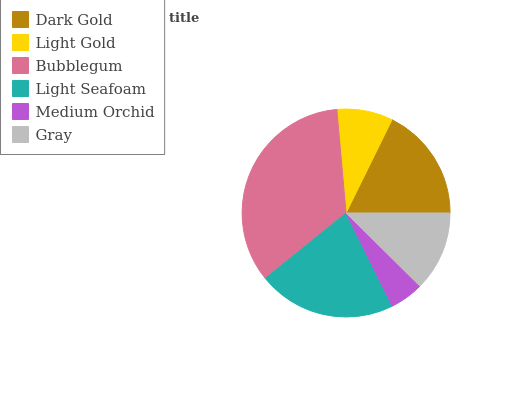Is Medium Orchid the minimum?
Answer yes or no. Yes. Is Bubblegum the maximum?
Answer yes or no. Yes. Is Light Gold the minimum?
Answer yes or no. No. Is Light Gold the maximum?
Answer yes or no. No. Is Dark Gold greater than Light Gold?
Answer yes or no. Yes. Is Light Gold less than Dark Gold?
Answer yes or no. Yes. Is Light Gold greater than Dark Gold?
Answer yes or no. No. Is Dark Gold less than Light Gold?
Answer yes or no. No. Is Dark Gold the high median?
Answer yes or no. Yes. Is Gray the low median?
Answer yes or no. Yes. Is Light Seafoam the high median?
Answer yes or no. No. Is Bubblegum the low median?
Answer yes or no. No. 